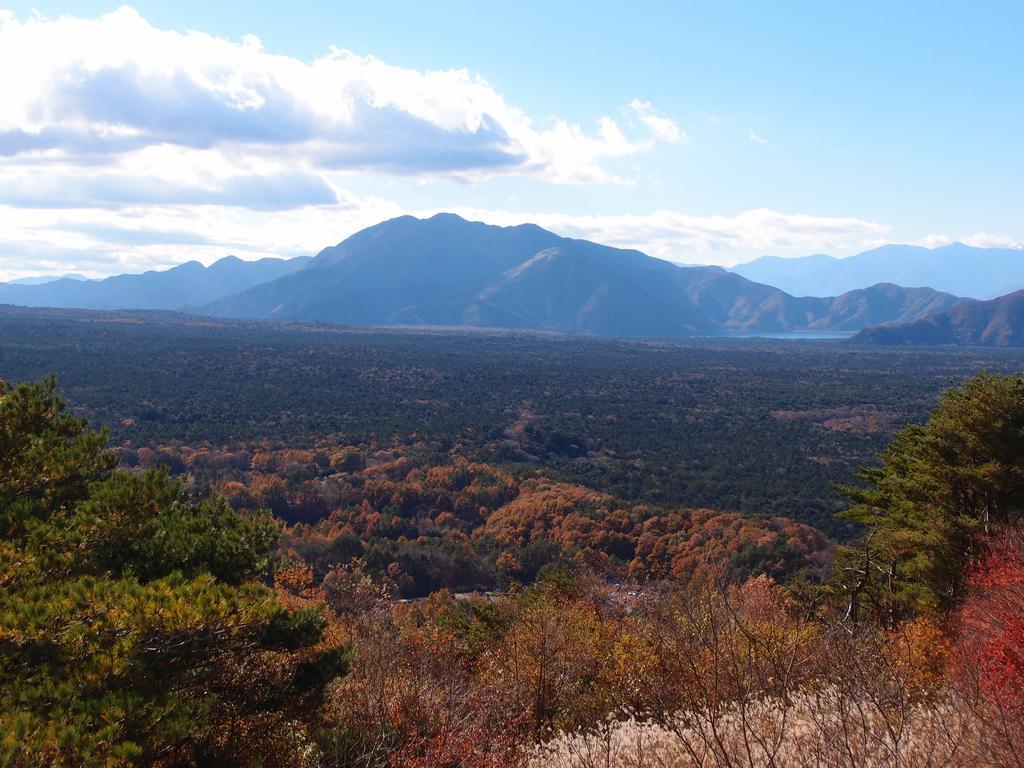Describe this image in one or two sentences. In this image, we can see some trees. There are hills in the middle of the image. There is a sky at the top of the image. 